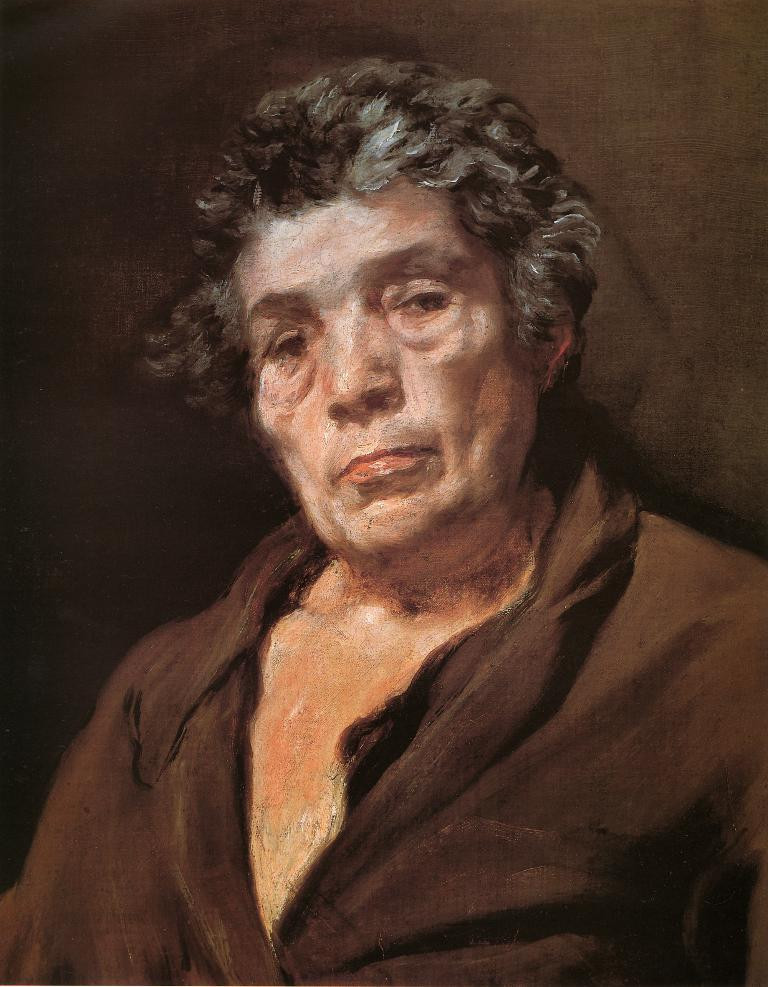What is depicted in the painting in the image? There is a painting of a man in the image. What can be observed about the background of the painting? The background of the image is light brown in color. What type of mitten is the man wearing in the painting? There is no mitten visible in the painting; the man is not wearing any gloves or mittens. 